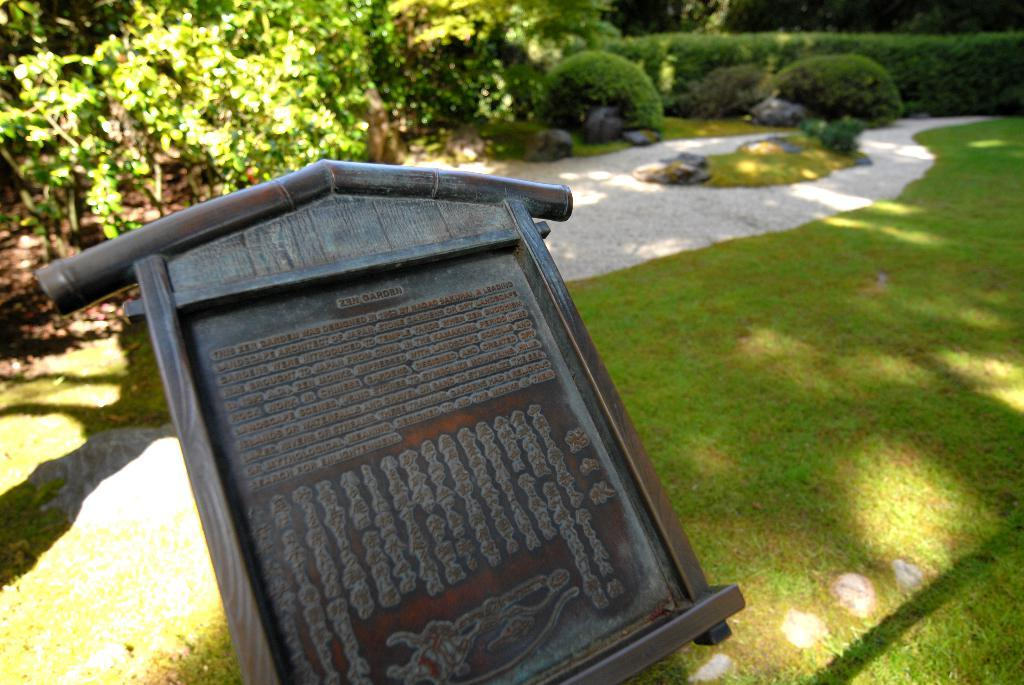What is the main object in the image? There is a board in the image. What can be seen in the background of the image? The background of the image includes plants. What color are the plants and trees in the background? The plants and trees in the background are green in color. What type of jam is being spread on the board in the image? There is no jam present in the image; it features a board and plants in the background. 